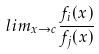Convert formula to latex. <formula><loc_0><loc_0><loc_500><loc_500>l i m _ { x \rightarrow c } \frac { f _ { i } ( x ) } { f _ { j } ( x ) }</formula> 